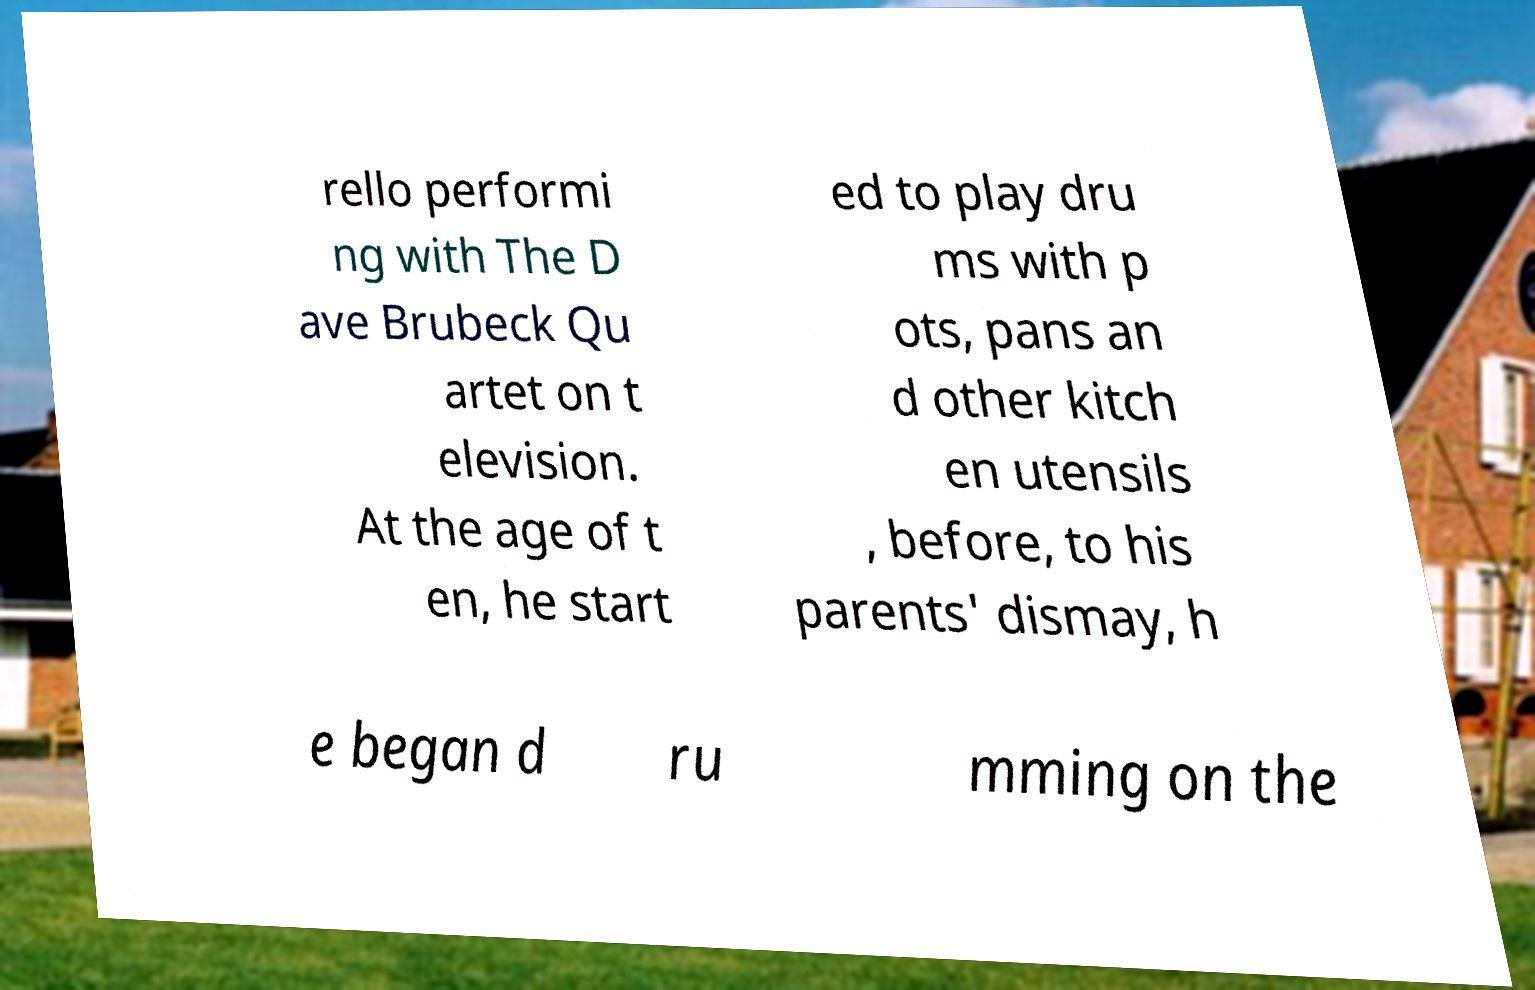Could you extract and type out the text from this image? rello performi ng with The D ave Brubeck Qu artet on t elevision. At the age of t en, he start ed to play dru ms with p ots, pans an d other kitch en utensils , before, to his parents' dismay, h e began d ru mming on the 